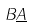Convert formula to latex. <formula><loc_0><loc_0><loc_500><loc_500>B \underline { A }</formula> 